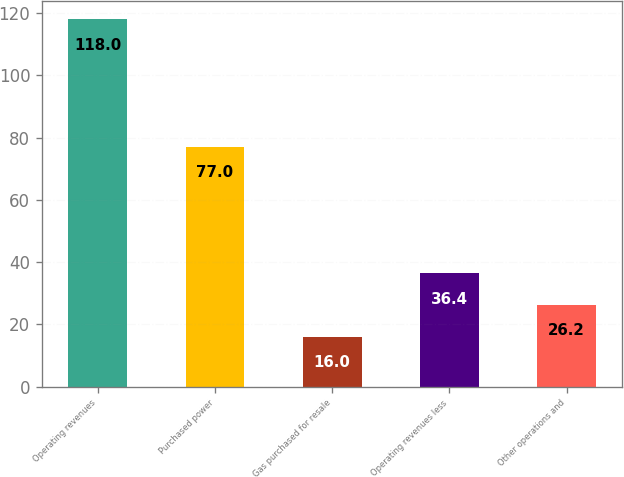Convert chart to OTSL. <chart><loc_0><loc_0><loc_500><loc_500><bar_chart><fcel>Operating revenues<fcel>Purchased power<fcel>Gas purchased for resale<fcel>Operating revenues less<fcel>Other operations and<nl><fcel>118<fcel>77<fcel>16<fcel>36.4<fcel>26.2<nl></chart> 